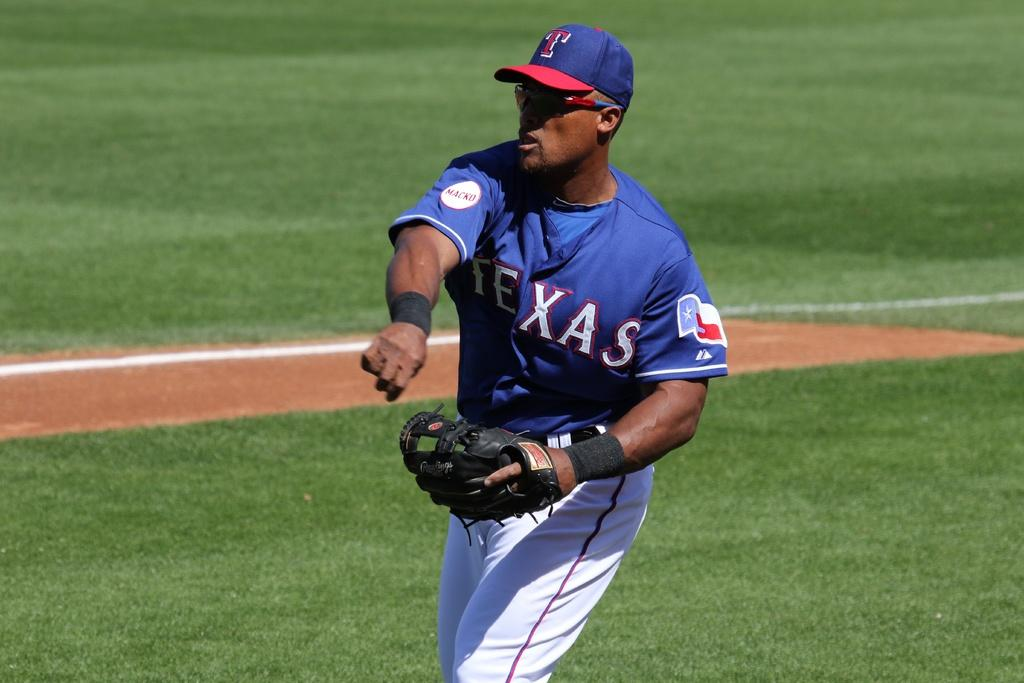Who is the main subject in the image? There is a man in the center of the image. What type of surface is visible at the bottom of the image? There is grass at the bottom of the image. What type of glove is the man wearing in the image? There is no glove visible in the image; the man is not wearing any gloves. 